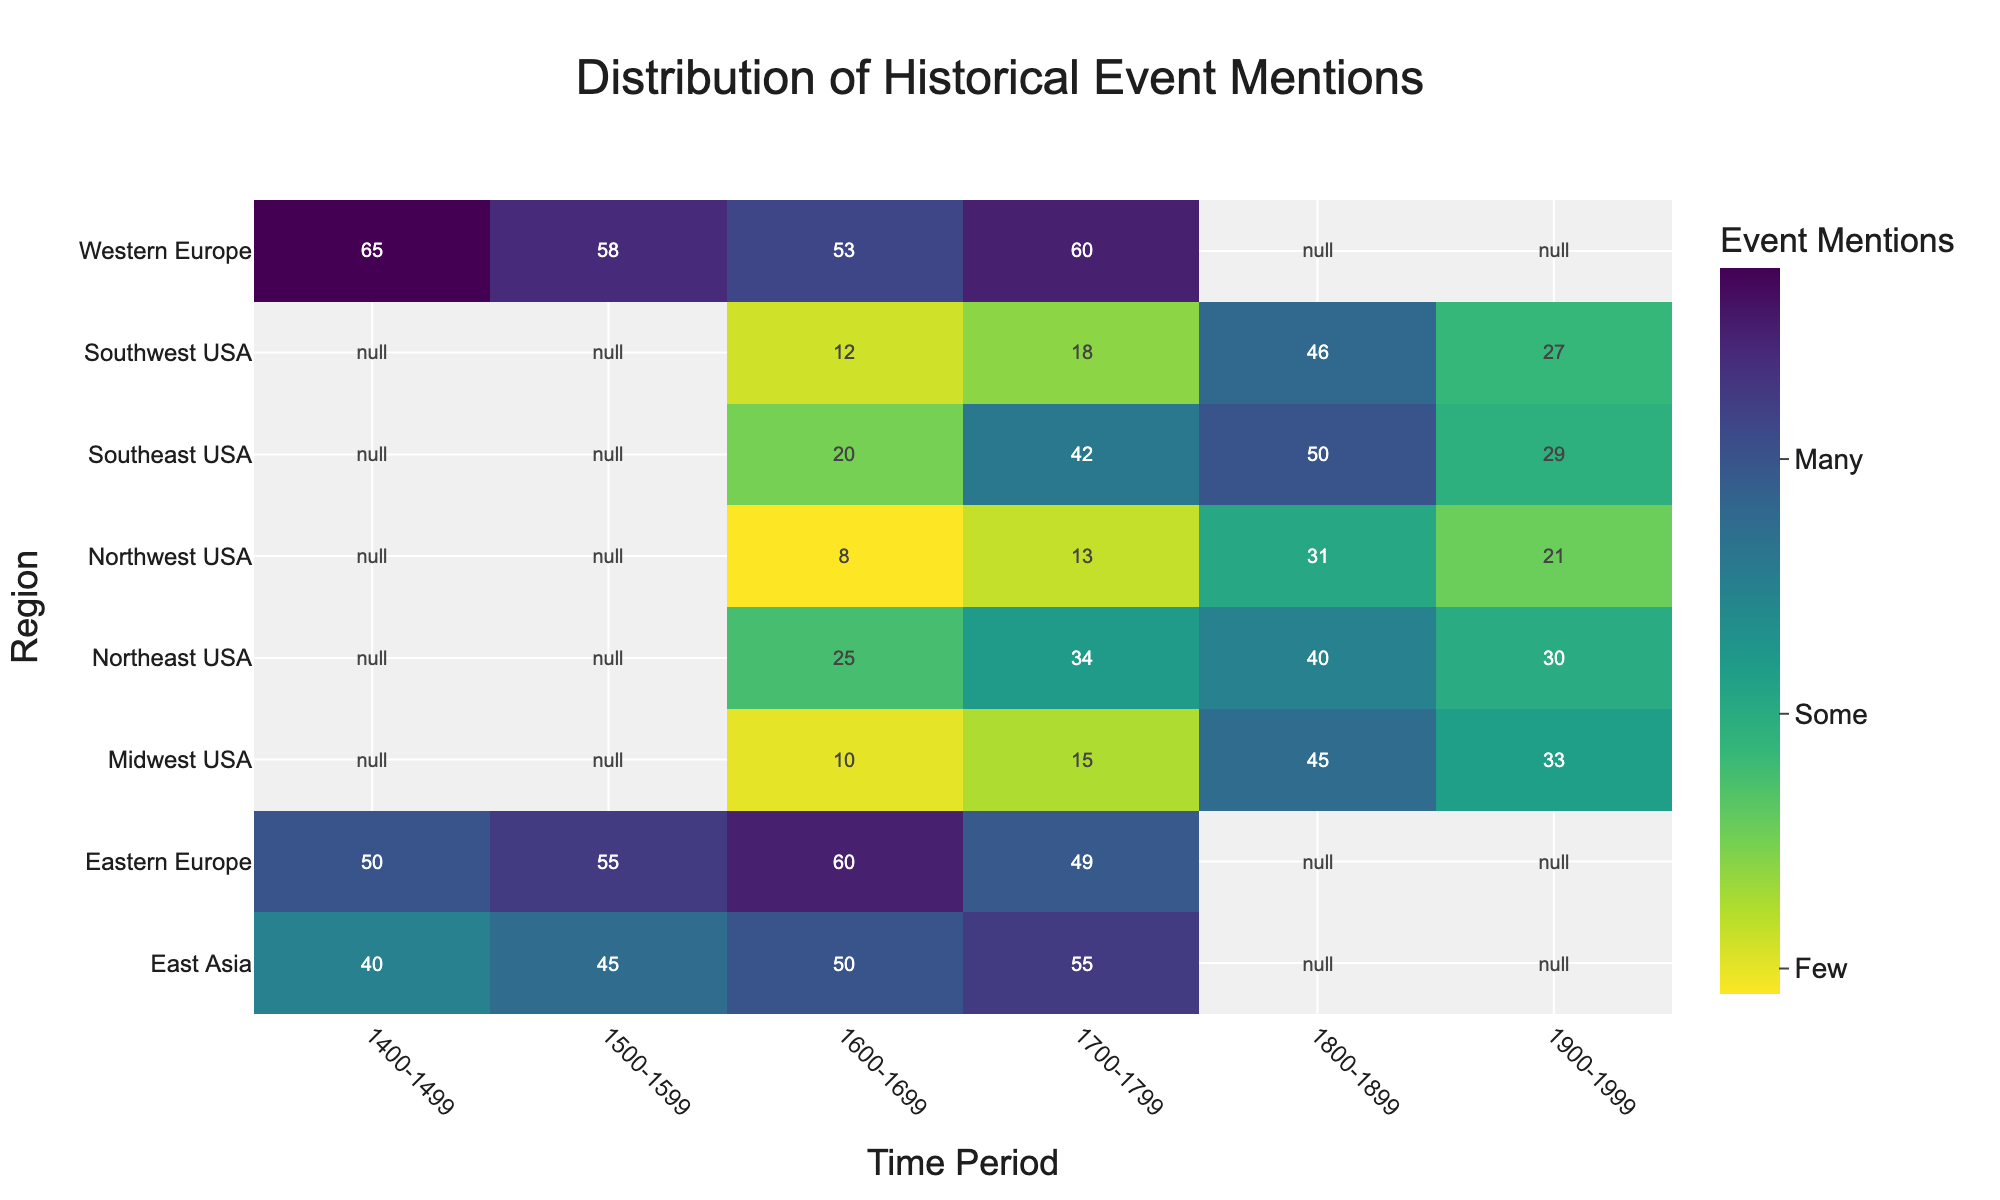Which region had the most historical event mentions in the 1600-1699 time period? Look for the highest value in the '1600-1699' column. Western Europe has the highest count with 53 mentions.
Answer: Western Europe How many historical event mentions are there in the Midwest USA from 1800-1899? Locate the cell that aligns with the 'Midwest USA' row and the '1800-1899' column. The value is 45.
Answer: 45 Which region had fewer mentions in the 1700-1799 time period: Northeast USA or Midwest USA? Compare the values for 'Northeast USA' and 'Midwest USA' in the '1700-1799' column. Northeast USA has 34 mentions, and Midwest USA has 15.
Answer: Midwest USA What is the sum of historical event mentions in Eastern Europe across the 1400-1499 and 1500-1599 periods? Add the values for Eastern Europe in the '1400-1499' and '1500-1599' columns: 50 + 55.
Answer: 105 Which region has the least mentions in the 1900-1999 period? Look for the lowest value in the '1900-1999' column. Northwest USA has the lowest number with 21 mentions.
Answer: Northwest USA How does the number of event mentions in the Southeast USA in the 1700-1799 period compare to that in the Southwest USA in the same period? Compare the respective values in the '1700-1799' column. Southeast USA has 42 mentions, and Southwest USA has 18.
Answer: Southeast USA What is the average number of historical event mentions across all regions in the 1800-1899 period? Sum the values in the '1800-1899' column and divide by the number of regions (7): (40 + 45 + 50 + 46 + 31 + 46) / 6 = 258 / 6 = 43.
Answer: 43 For the 1600-1699 period, which has more historical event mentions: Northeast USA or Western Europe? Compare the values for 'Northeast USA' and 'Western Europe' in the '1600-1699' column. Northeast USA has 25 mentions, and Western Europe has 53.
Answer: Western Europe 